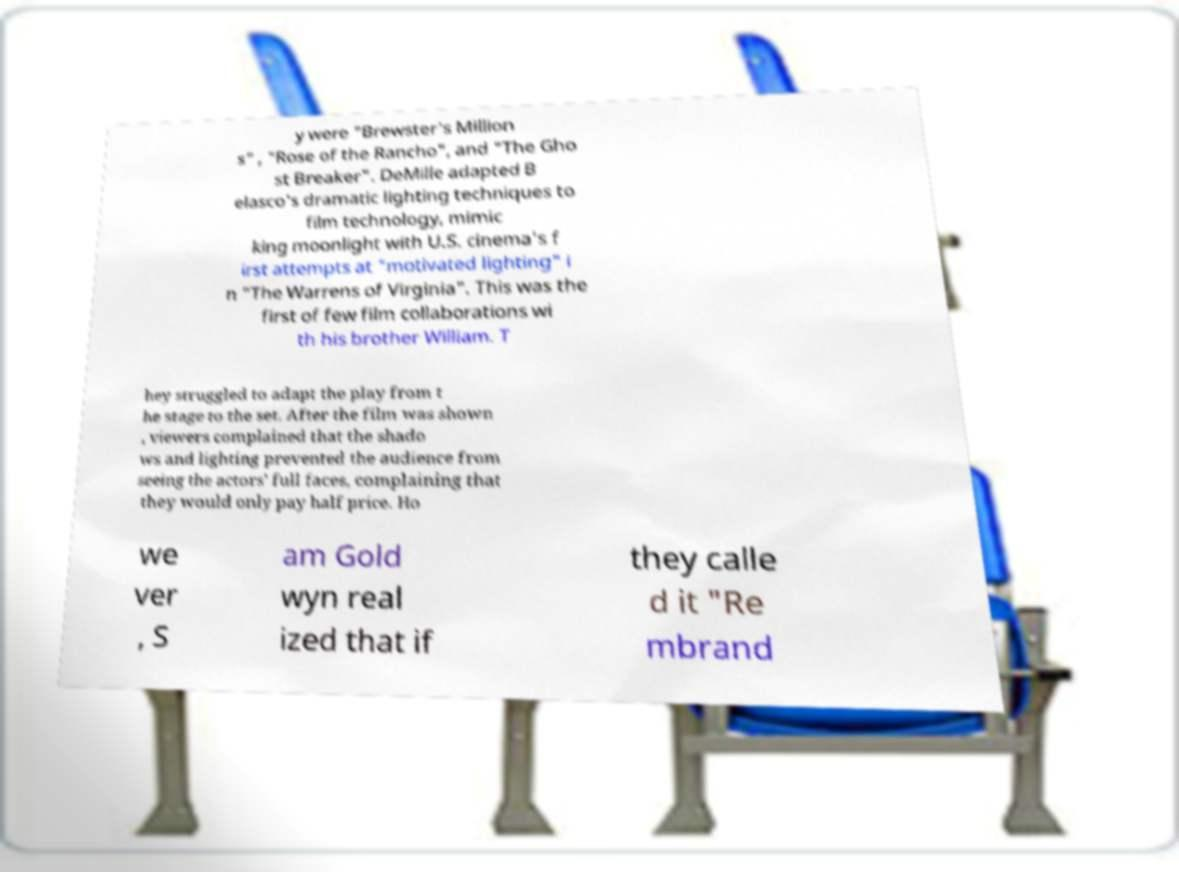Can you read and provide the text displayed in the image?This photo seems to have some interesting text. Can you extract and type it out for me? y were "Brewster's Million s" , "Rose of the Rancho", and "The Gho st Breaker". DeMille adapted B elasco's dramatic lighting techniques to film technology, mimic king moonlight with U.S. cinema's f irst attempts at "motivated lighting" i n "The Warrens of Virginia". This was the first of few film collaborations wi th his brother William. T hey struggled to adapt the play from t he stage to the set. After the film was shown , viewers complained that the shado ws and lighting prevented the audience from seeing the actors' full faces, complaining that they would only pay half price. Ho we ver , S am Gold wyn real ized that if they calle d it "Re mbrand 